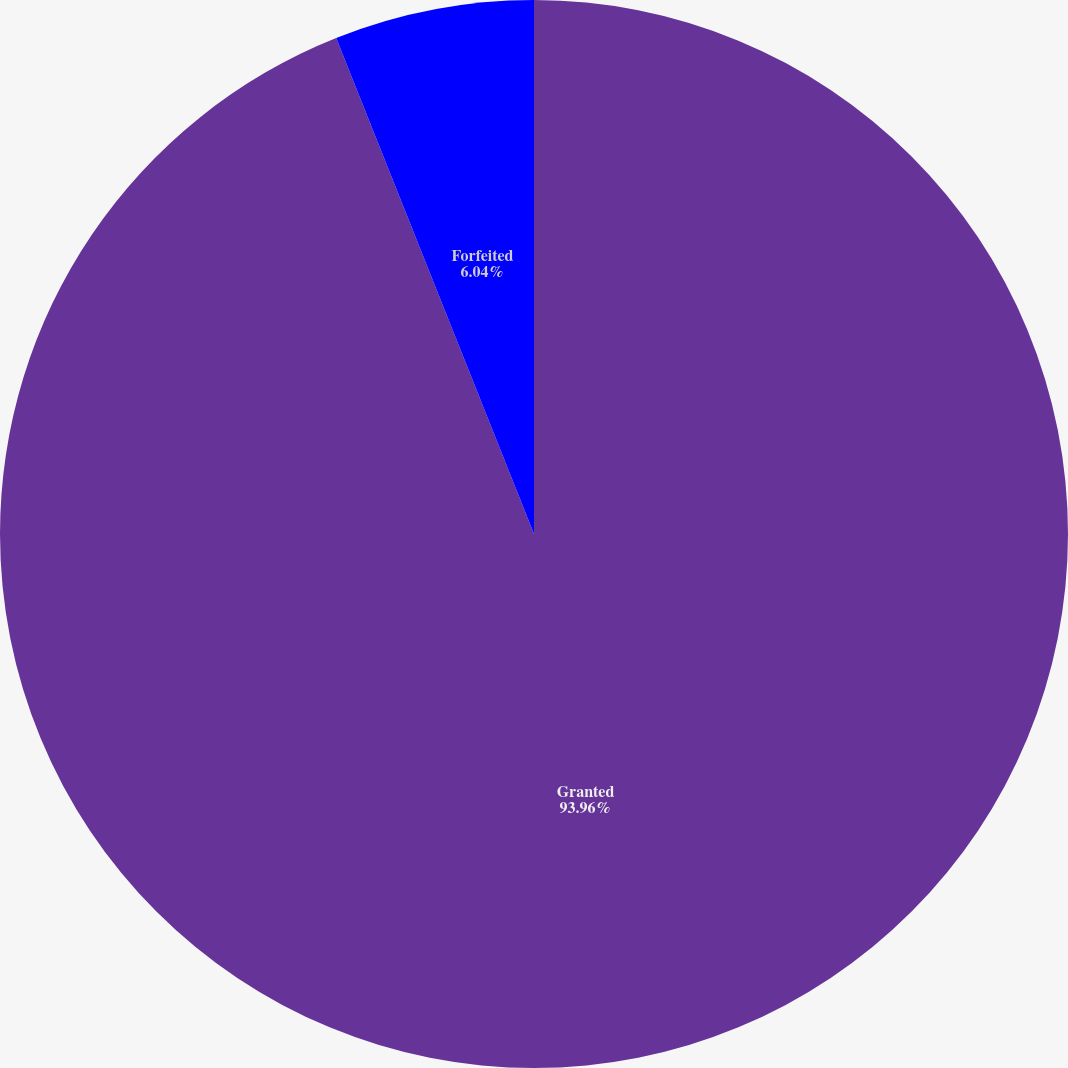Convert chart. <chart><loc_0><loc_0><loc_500><loc_500><pie_chart><fcel>Granted<fcel>Forfeited<nl><fcel>93.96%<fcel>6.04%<nl></chart> 